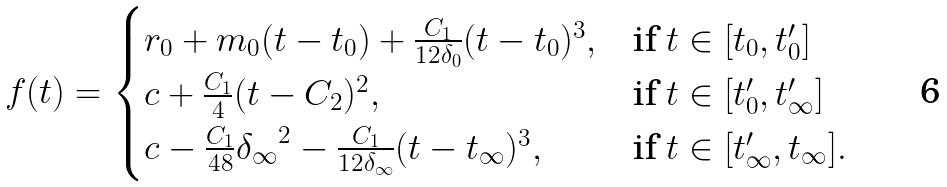Convert formula to latex. <formula><loc_0><loc_0><loc_500><loc_500>\begin{array} { c } f ( t ) = \begin{cases} r _ { 0 } + m _ { 0 } ( t - t _ { 0 } ) + \frac { C _ { 1 } } { 1 2 \delta _ { 0 } } ( t - t _ { 0 } ) ^ { 3 } , & \text {if $t\in[t_{0}, t_{0}^{\prime}]$} \\ c + \frac { C _ { 1 } } { 4 } ( t - C _ { 2 } ) ^ { 2 } , & \text {if $t\in[t_{0}^{\prime},t_{\infty}^{\prime}]$} \\ c - \frac { C _ { 1 } } { 4 8 } { \delta _ { \infty } } ^ { 2 } - \frac { C _ { 1 } } { 1 2 \delta _ { \infty } } ( t - t _ { \infty } ) ^ { 3 } , & \text {if $t\in[t_{\infty}^{\prime}, t_{\infty}]$} . \end{cases} \end{array}</formula> 